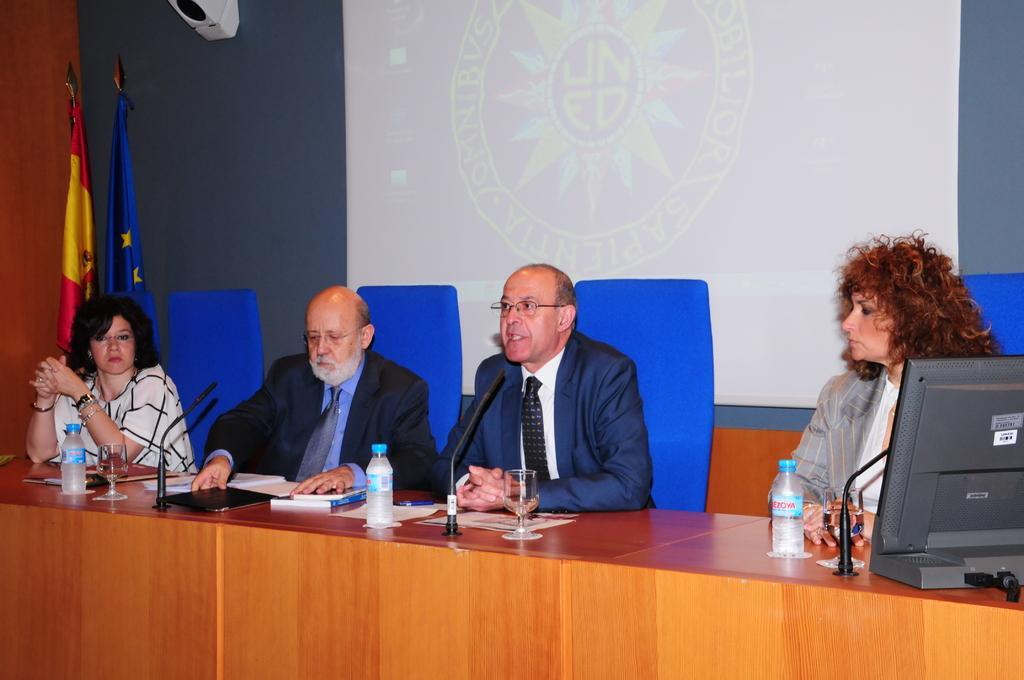In one or two sentences, can you explain what this image depicts? In this picture we can see four persons the person in the middle is talking and at right side the woman is listening to him, on left side man is listening and also woman is listening to the person. In front of them there is table on table we can see monitor,bottle,glass,books and at the background we can see a screen and flags with a pole where left side woman is wearing a beautiful watch and this middle person is talking through the mic. 